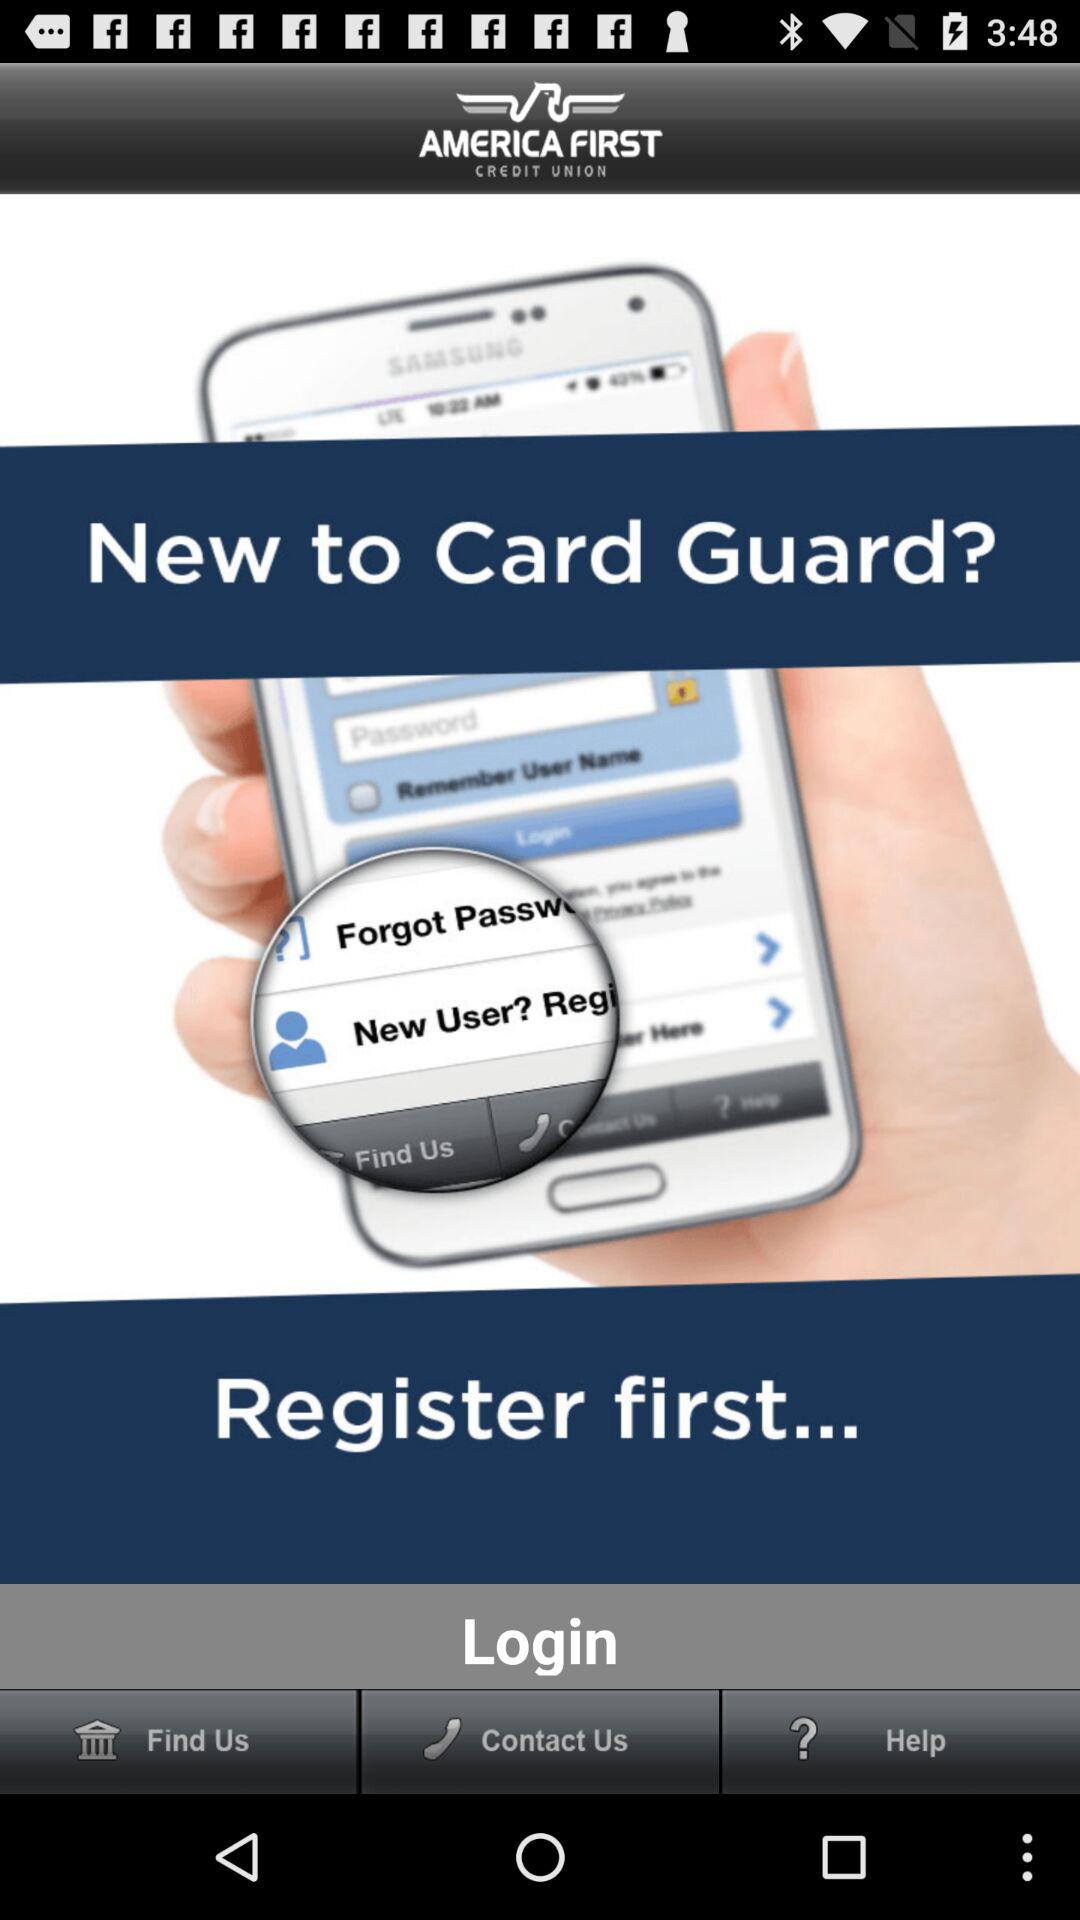What is the name of the application? The name of the application is "AMERICA FIRST CREDIT UNION". 